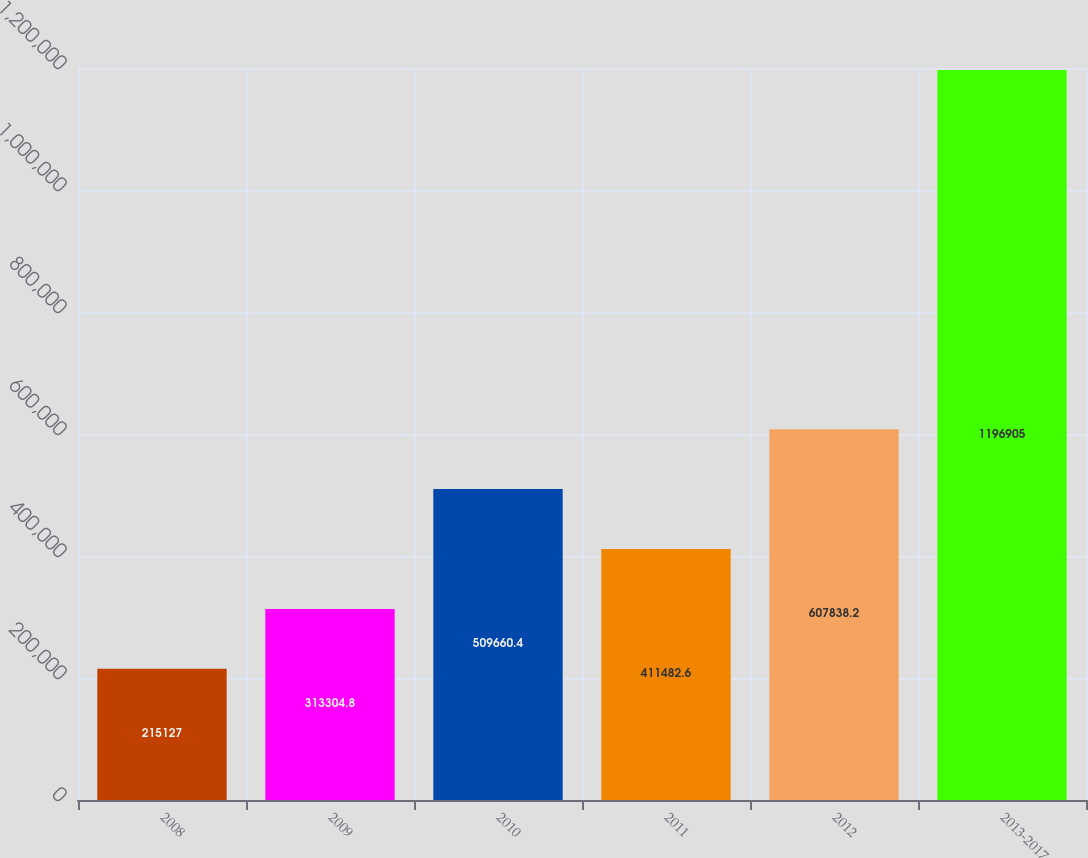Convert chart. <chart><loc_0><loc_0><loc_500><loc_500><bar_chart><fcel>2008<fcel>2009<fcel>2010<fcel>2011<fcel>2012<fcel>2013-2017<nl><fcel>215127<fcel>313305<fcel>509660<fcel>411483<fcel>607838<fcel>1.1969e+06<nl></chart> 